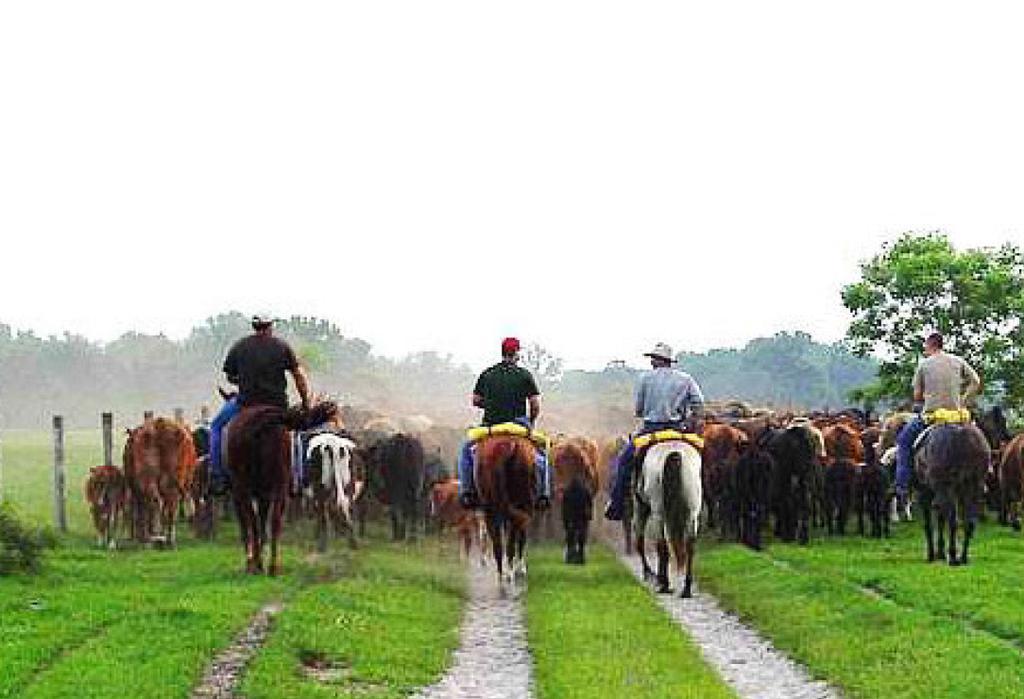Can you describe this image briefly? In this image there is the sky truncated towards the top of the image, there are trees, there is a tree truncated towards the left of the image, there is a a tree truncated towards the right of the image, there are horses, there are persons on the horses, there is grass truncated towards the bottom of the image, there is grass truncated towards the left of the image, there is grass truncated towards the right of the image. 